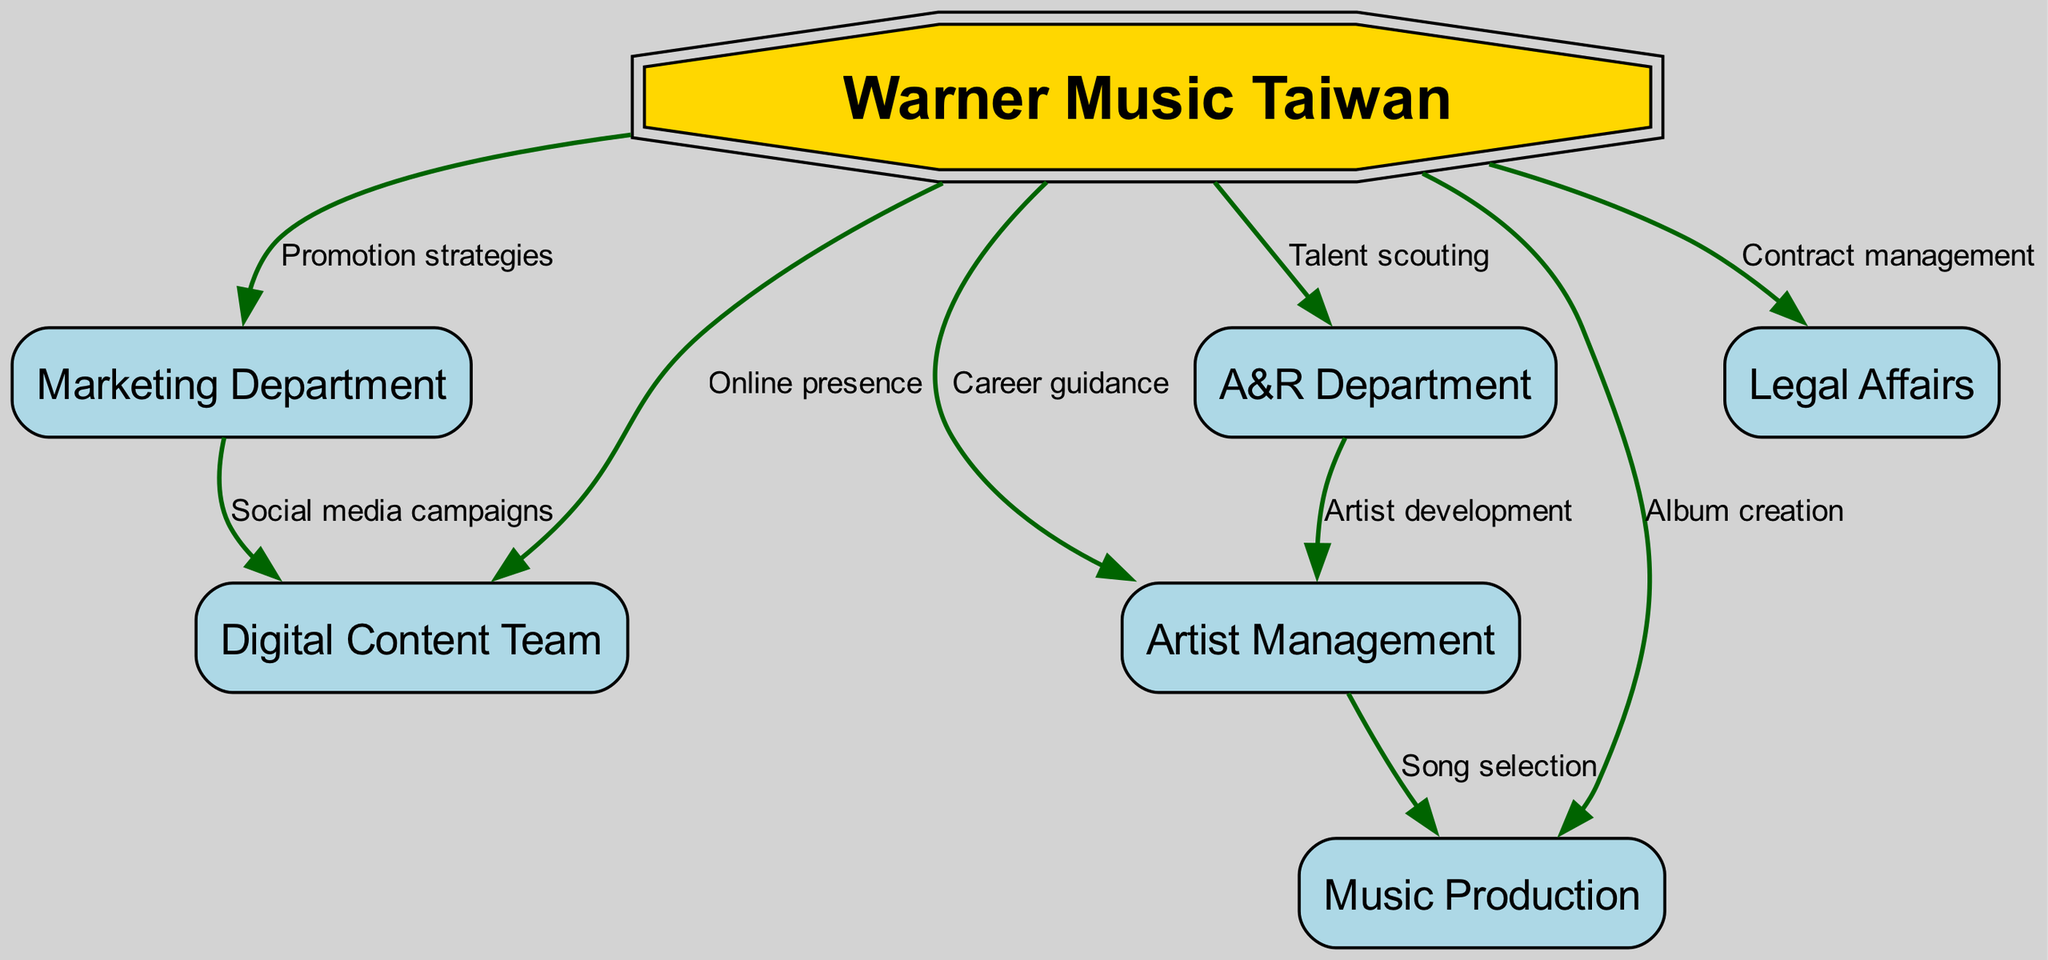What is the label of the central node in the diagram? The central node in the diagram represents the major record label, which is "Warner Music Taiwan." This is visually indicated by its distinct shape and bold coloring compared to other nodes.
Answer: Warner Music Taiwan How many departments are directly connected to the central node? To determine the number of departments connected to the central node, we count the edges leading from "Warner Music Taiwan" to its connected nodes. There are a total of six direct connections.
Answer: 6 What is the role of the A&R Department in relation to Artist Management? The A&R Department has a direct connection to Artist Management, indicating their collaborative role in "Artist development," highlighting their involvement in nurturing and guiding artists further in their careers.
Answer: Artist development Which department focuses on "Social media campaigns"? The Marketing Department is directly linked to the Digital Content Team via the edge labeled "Social media campaigns," showing that this department is primarily responsible for such activities.
Answer: Marketing Department What function does the Legal Affairs department serve? The Legal Affairs department is associated with "Contract management," signifying its role in overseeing legal agreements and protecting the label’s interests, as suggested by the direct edge connecting the two.
Answer: Contract management Identify the node that is responsible for "Online presence." The node connected to "Online presence" is the Digital Content Team, which is indicated by the connection to the central node that specifies its role in managing the label's digital activities and visibility.
Answer: Digital Content Team How does the Music Production relate to Artist Management? The flow from Artist Management to Music Production indicates that Artist Management aids in "Song selection," showcasing the interactive relationship in deciding which songs to record based on the artist's style and image.
Answer: Song selection Which department is primarily involved in "Album creation"? There is a direct edge from the central node, Warner Music Taiwan, to Music Production that indicates this department’s main role involves "Album creation," relating to the overall production of music for artists under the label.
Answer: Music Production What color scheme is used for the nodes representing departments? The nodes representing the departments are filled with a light blue color, which is distinct from the golden color of the central node, indicating the hierarchy and organization within the record label.
Answer: Light blue 